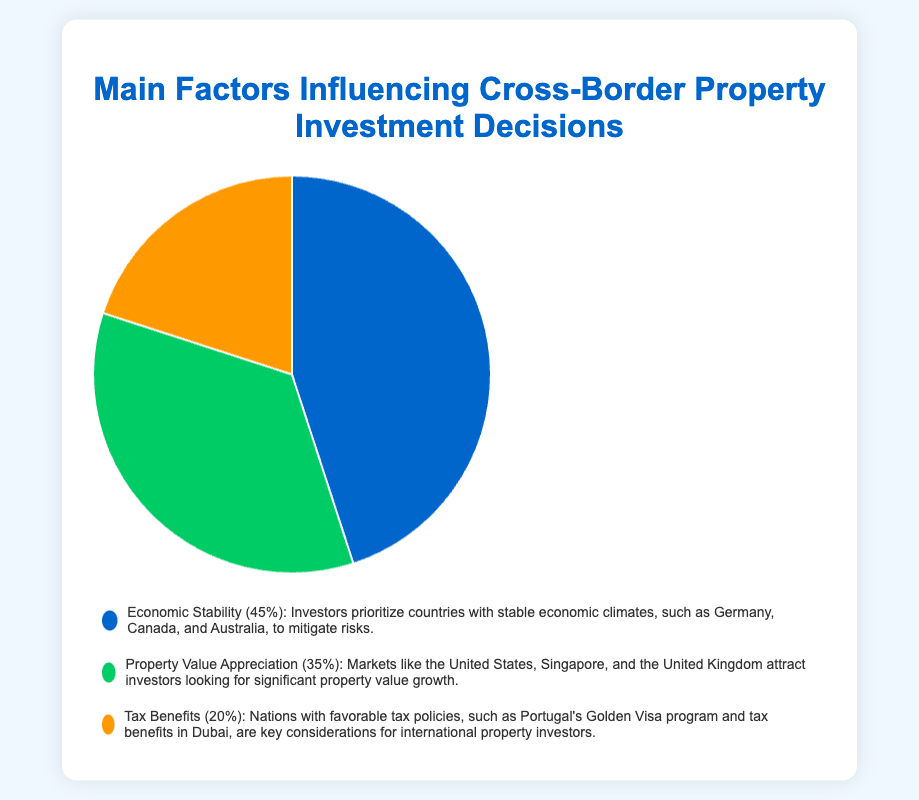What is the most influential factor in cross-border property investment decisions? The pie chart shows that the larger segment corresponds to Economic Stability at 45%, indicating it is the most influential factor.
Answer: Economic Stability What percentage of investors consider Property Value Appreciation as their main factor? According to the pie chart, the segment representing Property Value Appreciation accounts for 35%.
Answer: 35% Which factor is the least influential in property investment decisions? The pie chart indicates that Tax Benefits, with a percentage of 20%, is the smallest segment, making it the least influential factor.
Answer: Tax Benefits How much more influential is Economic Stability compared to Tax Benefits? Economic Stability is represented by 45%, and Tax Benefits by 20%. The difference is 45% - 20% = 25%.
Answer: 25% What is the combined percentage of investors who prioritize either Economic Stability or Property Value Appreciation? The percentage for Economic Stability is 45%, and for Property Value Appreciation, it is 35%. Adding these together gives 45% + 35% = 80%.
Answer: 80% Which factor is represented by the green segment in the pie chart? Observing the chart, the green segment is associated with Property Value Appreciation.
Answer: Property Value Appreciation What is the ratio of Property Value Appreciation to Tax Benefits? Property Value Appreciation has a percentage of 35%, and Tax Benefits has 20%. The ratio is 35:20, which can be simplified to 7:4.
Answer: 7:4 What is the difference between the percentages of the two largest factors? Economic Stability is 45%, and Property Value Appreciation is 35%. The difference is 45% - 35% = 10%.
Answer: 10% Which countries are associated with Economic Stability as a deciding factor? According to the description in the legend, countries like Germany, Canada, and Australia are associated with Economic Stability.
Answer: Germany, Canada, and Australia If you combine Tax Benefits and Property Value Appreciation, will they surpass Economic Stability in influence? Tax Benefits have 20% and Property Value Appreciation has 35%. Combined, they make up 20% + 35% = 55%, which is greater than Economic Stability's 45%.
Answer: Yes 